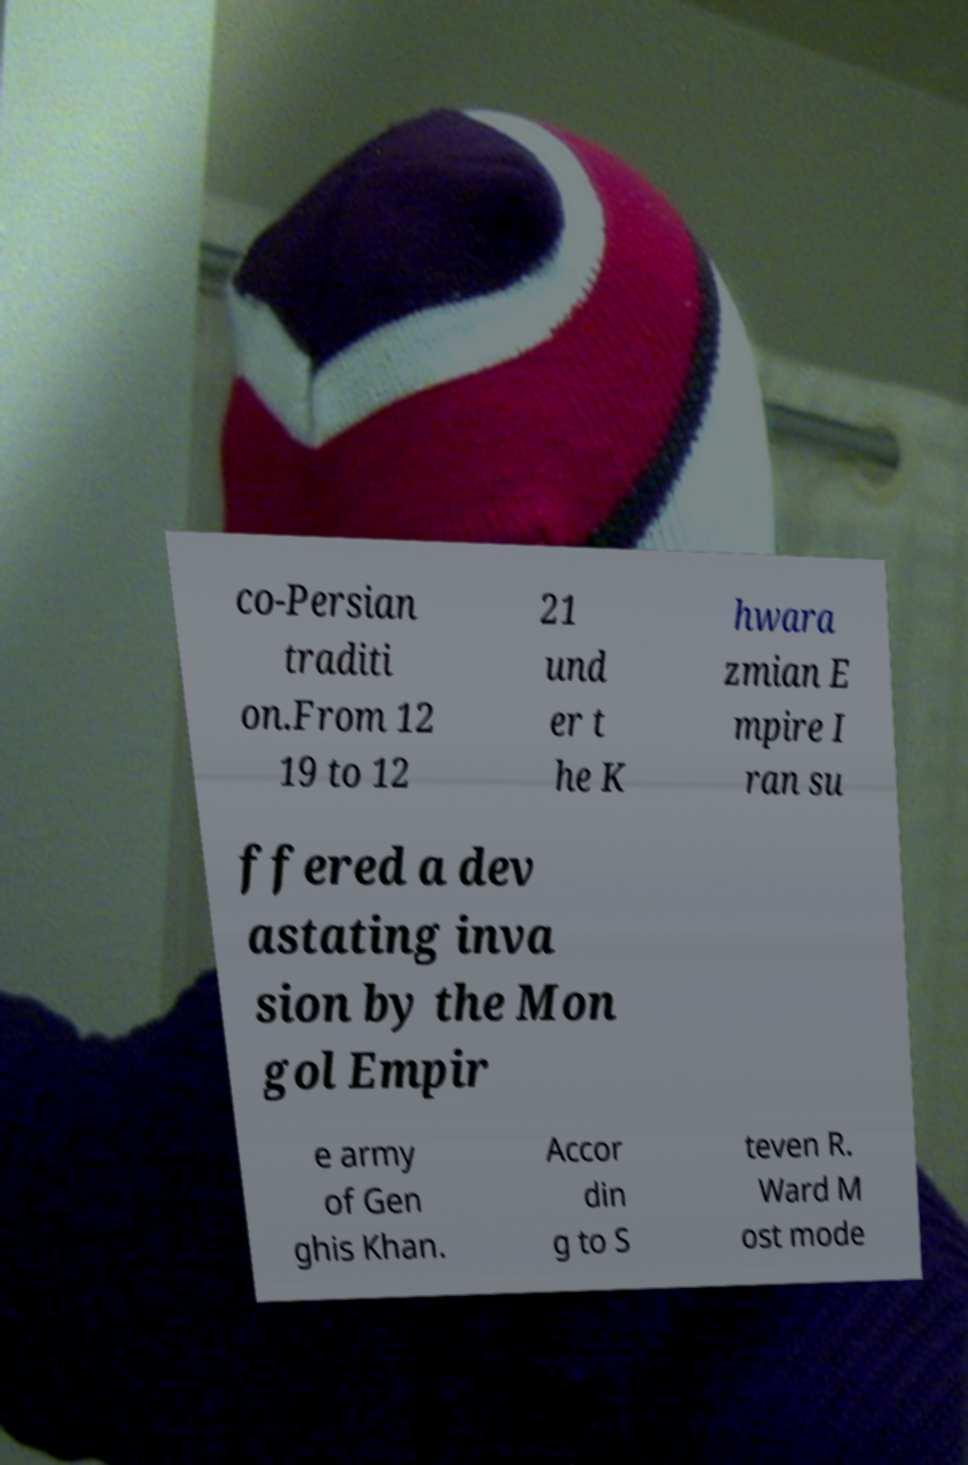For documentation purposes, I need the text within this image transcribed. Could you provide that? co-Persian traditi on.From 12 19 to 12 21 und er t he K hwara zmian E mpire I ran su ffered a dev astating inva sion by the Mon gol Empir e army of Gen ghis Khan. Accor din g to S teven R. Ward M ost mode 